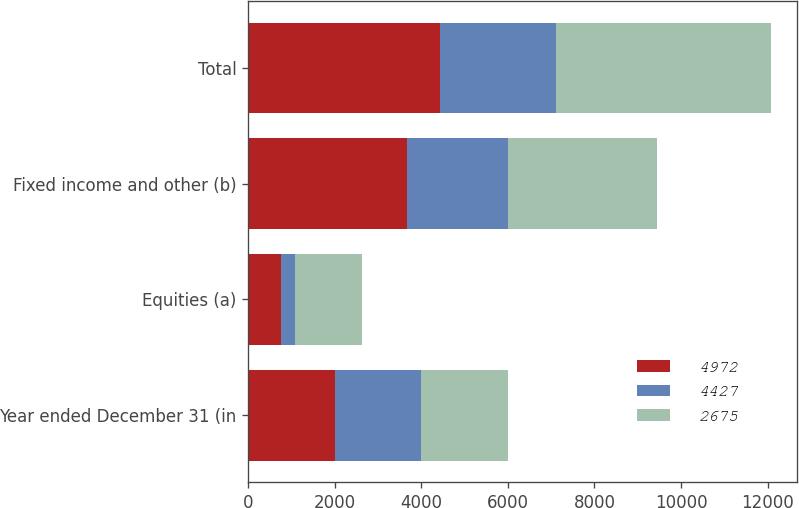Convert chart. <chart><loc_0><loc_0><loc_500><loc_500><stacked_bar_chart><ecel><fcel>Year ended December 31 (in<fcel>Equities (a)<fcel>Fixed income and other (b)<fcel>Total<nl><fcel>4972<fcel>2003<fcel>764<fcel>3663<fcel>4427<nl><fcel>4427<fcel>2002<fcel>331<fcel>2344<fcel>2675<nl><fcel>2675<fcel>2001<fcel>1541<fcel>3431<fcel>4972<nl></chart> 